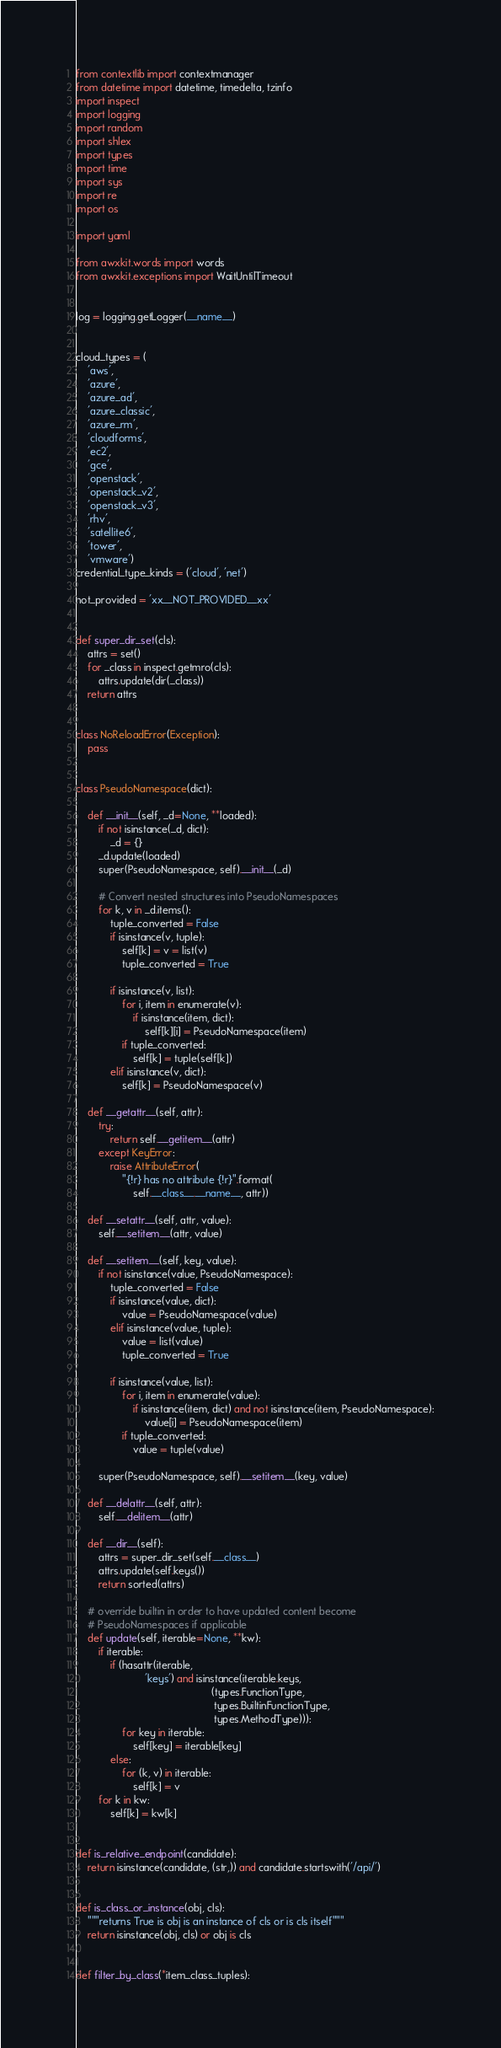<code> <loc_0><loc_0><loc_500><loc_500><_Python_>from contextlib import contextmanager
from datetime import datetime, timedelta, tzinfo
import inspect
import logging
import random
import shlex
import types
import time
import sys
import re
import os

import yaml

from awxkit.words import words
from awxkit.exceptions import WaitUntilTimeout


log = logging.getLogger(__name__)


cloud_types = (
    'aws',
    'azure',
    'azure_ad',
    'azure_classic',
    'azure_rm',
    'cloudforms',
    'ec2',
    'gce',
    'openstack',
    'openstack_v2',
    'openstack_v3',
    'rhv',
    'satellite6',
    'tower',
    'vmware')
credential_type_kinds = ('cloud', 'net')

not_provided = 'xx__NOT_PROVIDED__xx'


def super_dir_set(cls):
    attrs = set()
    for _class in inspect.getmro(cls):
        attrs.update(dir(_class))
    return attrs


class NoReloadError(Exception):
    pass


class PseudoNamespace(dict):

    def __init__(self, _d=None, **loaded):
        if not isinstance(_d, dict):
            _d = {}
        _d.update(loaded)
        super(PseudoNamespace, self).__init__(_d)

        # Convert nested structures into PseudoNamespaces
        for k, v in _d.items():
            tuple_converted = False
            if isinstance(v, tuple):
                self[k] = v = list(v)
                tuple_converted = True

            if isinstance(v, list):
                for i, item in enumerate(v):
                    if isinstance(item, dict):
                        self[k][i] = PseudoNamespace(item)
                if tuple_converted:
                    self[k] = tuple(self[k])
            elif isinstance(v, dict):
                self[k] = PseudoNamespace(v)

    def __getattr__(self, attr):
        try:
            return self.__getitem__(attr)
        except KeyError:
            raise AttributeError(
                "{!r} has no attribute {!r}".format(
                    self.__class__.__name__, attr))

    def __setattr__(self, attr, value):
        self.__setitem__(attr, value)

    def __setitem__(self, key, value):
        if not isinstance(value, PseudoNamespace):
            tuple_converted = False
            if isinstance(value, dict):
                value = PseudoNamespace(value)
            elif isinstance(value, tuple):
                value = list(value)
                tuple_converted = True

            if isinstance(value, list):
                for i, item in enumerate(value):
                    if isinstance(item, dict) and not isinstance(item, PseudoNamespace):
                        value[i] = PseudoNamespace(item)
                if tuple_converted:
                    value = tuple(value)

        super(PseudoNamespace, self).__setitem__(key, value)

    def __delattr__(self, attr):
        self.__delitem__(attr)

    def __dir__(self):
        attrs = super_dir_set(self.__class__)
        attrs.update(self.keys())
        return sorted(attrs)

    # override builtin in order to have updated content become
    # PseudoNamespaces if applicable
    def update(self, iterable=None, **kw):
        if iterable:
            if (hasattr(iterable,
                        'keys') and isinstance(iterable.keys,
                                               (types.FunctionType,
                                                types.BuiltinFunctionType,
                                                types.MethodType))):
                for key in iterable:
                    self[key] = iterable[key]
            else:
                for (k, v) in iterable:
                    self[k] = v
        for k in kw:
            self[k] = kw[k]


def is_relative_endpoint(candidate):
    return isinstance(candidate, (str,)) and candidate.startswith('/api/')


def is_class_or_instance(obj, cls):
    """returns True is obj is an instance of cls or is cls itself"""
    return isinstance(obj, cls) or obj is cls


def filter_by_class(*item_class_tuples):</code> 